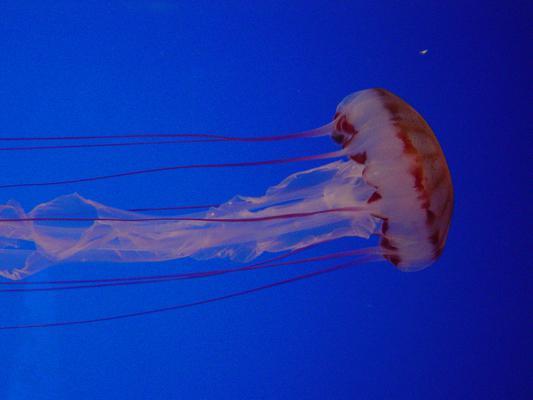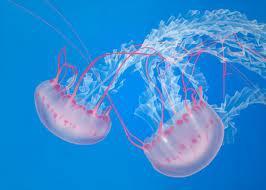The first image is the image on the left, the second image is the image on the right. Assess this claim about the two images: "There are three jellyfish in total.". Correct or not? Answer yes or no. Yes. 